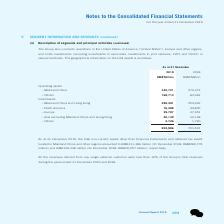According to Tencent's financial document, How much did the total non-current assets other than financial instruments as at 31 December 2019 amount to? According to the financial document, RMB311,386 million. The relevant text states: "d in Mainland China and other regions amounted to RMB311,386 million (31 December 2018: RMB282,774..." Also, How much did the deferred tax assets located in Mainland China and other regions as at 31 December 2019 amount to? According to the financial document, RMB136,338 million. The relevant text states: "million) and RMB136,338 million (31 December 2018: RMB65,057 million), respectively...." Also, How much is the operating assets in mainland china as at 31 December 2019? According to the financial document, 345,721 (in millions). The relevant text states: "– Mainland China 345,721 270,373..." Also, can you calculate: How much is the total operating assets as at 31 December 2019? Based on the calculation: 345,721+168,714, the result is 514435 (in millions). This is based on the information: "– Others 168,714 83,962 – Mainland China 345,721 270,373..." The key data points involved are: 168,714, 345,721. Also, can you calculate: How much is the difference between 2018 year end and 2019 year end europe investments? Based on the calculation: 37,451-29,707, the result is 7744 (in millions). This is based on the information: "– Europe 29,707 37,451 – Europe 29,707 37,451..." The key data points involved are: 29,707, 37,451. Also, can you calculate: What is the difference between total operating assets and investments of 2018 year end and 2019 year end? Based on the calculation: 953,986-723,521, the result is 230465 (in millions). This is based on the information: "953,986 723,521 953,986 723,521..." The key data points involved are: 723,521, 953,986. 